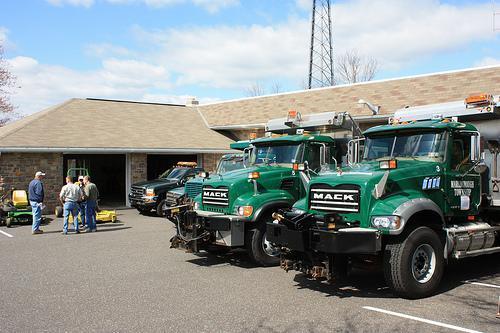How many men?
Give a very brief answer. 4. 